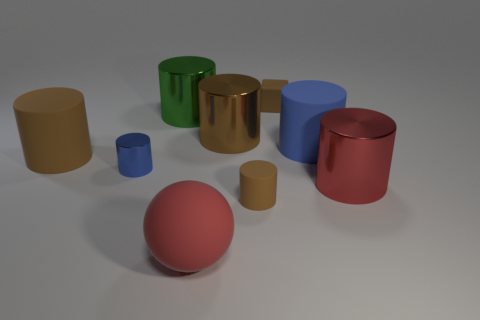What material is the green object?
Your response must be concise. Metal. There is a red thing that is the same shape as the brown shiny object; what material is it?
Give a very brief answer. Metal. There is a thing behind the green cylinder; is its size the same as the blue metallic cylinder?
Give a very brief answer. Yes. There is a metallic cylinder that is behind the blue rubber object and in front of the green cylinder; what size is it?
Give a very brief answer. Large. How many metallic cylinders are the same size as the brown rubber block?
Offer a very short reply. 1. What number of brown shiny cylinders are in front of the large matte cylinder on the right side of the red rubber object?
Provide a short and direct response. 0. There is a cylinder that is on the left side of the blue metal thing; is it the same color as the small metallic cylinder?
Provide a short and direct response. No. There is a brown thing that is on the left side of the big brown object on the right side of the green object; are there any big rubber cylinders right of it?
Provide a succinct answer. Yes. What is the shape of the rubber thing that is both behind the big red cylinder and on the left side of the brown metallic thing?
Your response must be concise. Cylinder. Is there a large shiny cylinder of the same color as the ball?
Your answer should be compact. Yes. 